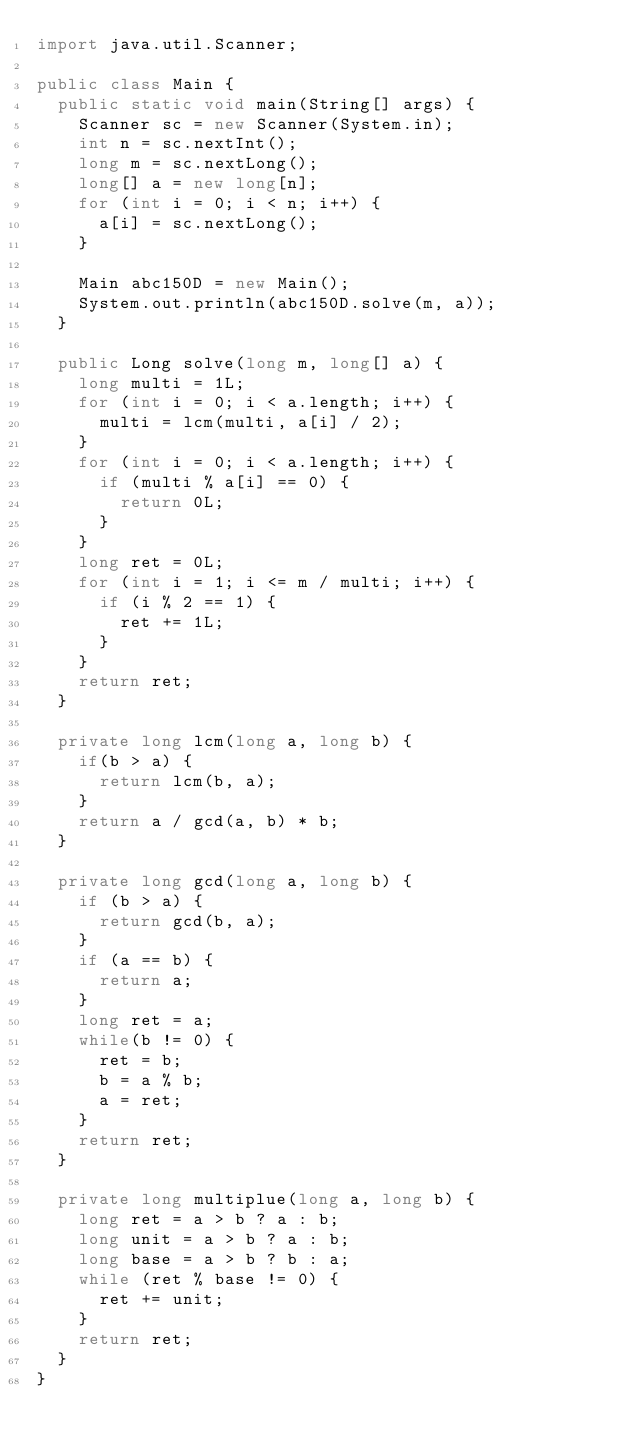Convert code to text. <code><loc_0><loc_0><loc_500><loc_500><_Java_>import java.util.Scanner;

public class Main {
  public static void main(String[] args) {
    Scanner sc = new Scanner(System.in);
    int n = sc.nextInt();
    long m = sc.nextLong();
    long[] a = new long[n];
    for (int i = 0; i < n; i++) {
      a[i] = sc.nextLong();
    }

    Main abc150D = new Main();
    System.out.println(abc150D.solve(m, a));
  }

  public Long solve(long m, long[] a) {
    long multi = 1L;
    for (int i = 0; i < a.length; i++) {
      multi = lcm(multi, a[i] / 2);
    }
    for (int i = 0; i < a.length; i++) {
      if (multi % a[i] == 0) {
        return 0L;
      }
    }
    long ret = 0L;
    for (int i = 1; i <= m / multi; i++) {
      if (i % 2 == 1) {
        ret += 1L;
      }
    }
    return ret;
  }

  private long lcm(long a, long b) {
    if(b > a) {
      return lcm(b, a);
    }
    return a / gcd(a, b) * b;
  }

  private long gcd(long a, long b) {
    if (b > a) {
      return gcd(b, a);
    }
    if (a == b) {
      return a;
    }
    long ret = a;
    while(b != 0) {
      ret = b;
      b = a % b;
      a = ret;
    }
    return ret;
  }

  private long multiplue(long a, long b) {
    long ret = a > b ? a : b;
    long unit = a > b ? a : b;
    long base = a > b ? b : a;
    while (ret % base != 0) {
      ret += unit;
    }
    return ret;
  }
}
</code> 